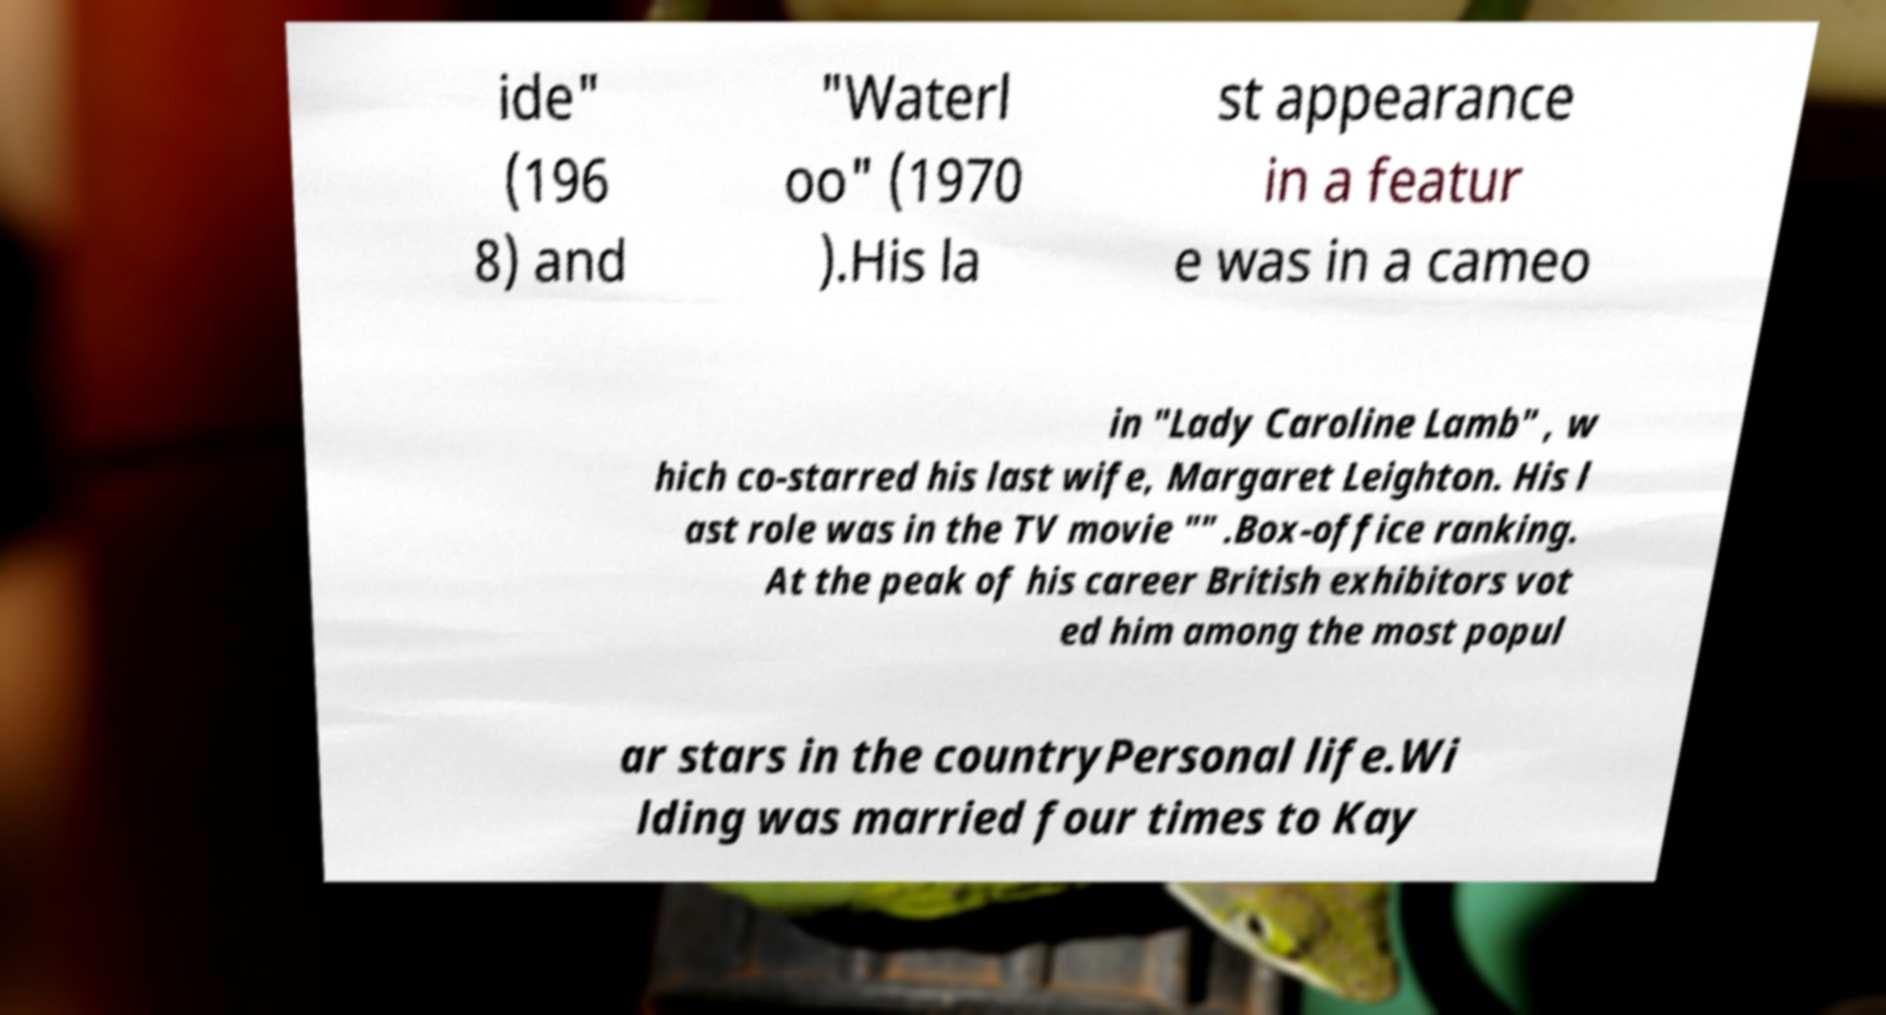Can you read and provide the text displayed in the image?This photo seems to have some interesting text. Can you extract and type it out for me? ide" (196 8) and "Waterl oo" (1970 ).His la st appearance in a featur e was in a cameo in "Lady Caroline Lamb" , w hich co-starred his last wife, Margaret Leighton. His l ast role was in the TV movie "" .Box-office ranking. At the peak of his career British exhibitors vot ed him among the most popul ar stars in the countryPersonal life.Wi lding was married four times to Kay 